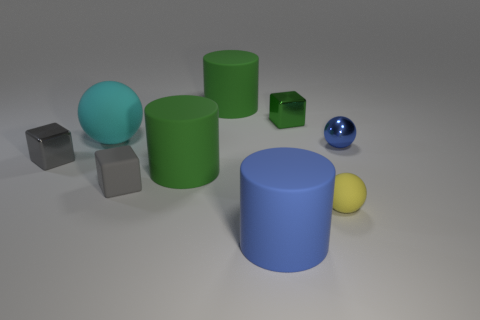There is a small green cube; how many cylinders are in front of it?
Your response must be concise. 2. There is a sphere that is left of the large cylinder behind the cyan ball; what is its material?
Give a very brief answer. Rubber. There is another sphere that is the same size as the yellow matte ball; what material is it?
Ensure brevity in your answer.  Metal. Are there any yellow shiny objects of the same size as the blue matte cylinder?
Provide a succinct answer. No. There is a object behind the green block; what is its color?
Keep it short and to the point. Green. There is a tiny metal object on the left side of the small green shiny block; are there any tiny rubber things that are to the left of it?
Offer a terse response. No. What number of other objects are there of the same color as the small matte ball?
Make the answer very short. 0. There is a ball that is in front of the tiny rubber cube; is it the same size as the green matte thing in front of the cyan object?
Offer a terse response. No. What size is the gray thing that is to the right of the rubber sphere behind the yellow matte ball?
Keep it short and to the point. Small. What material is the thing that is in front of the small gray metallic thing and to the right of the tiny green thing?
Provide a succinct answer. Rubber. 